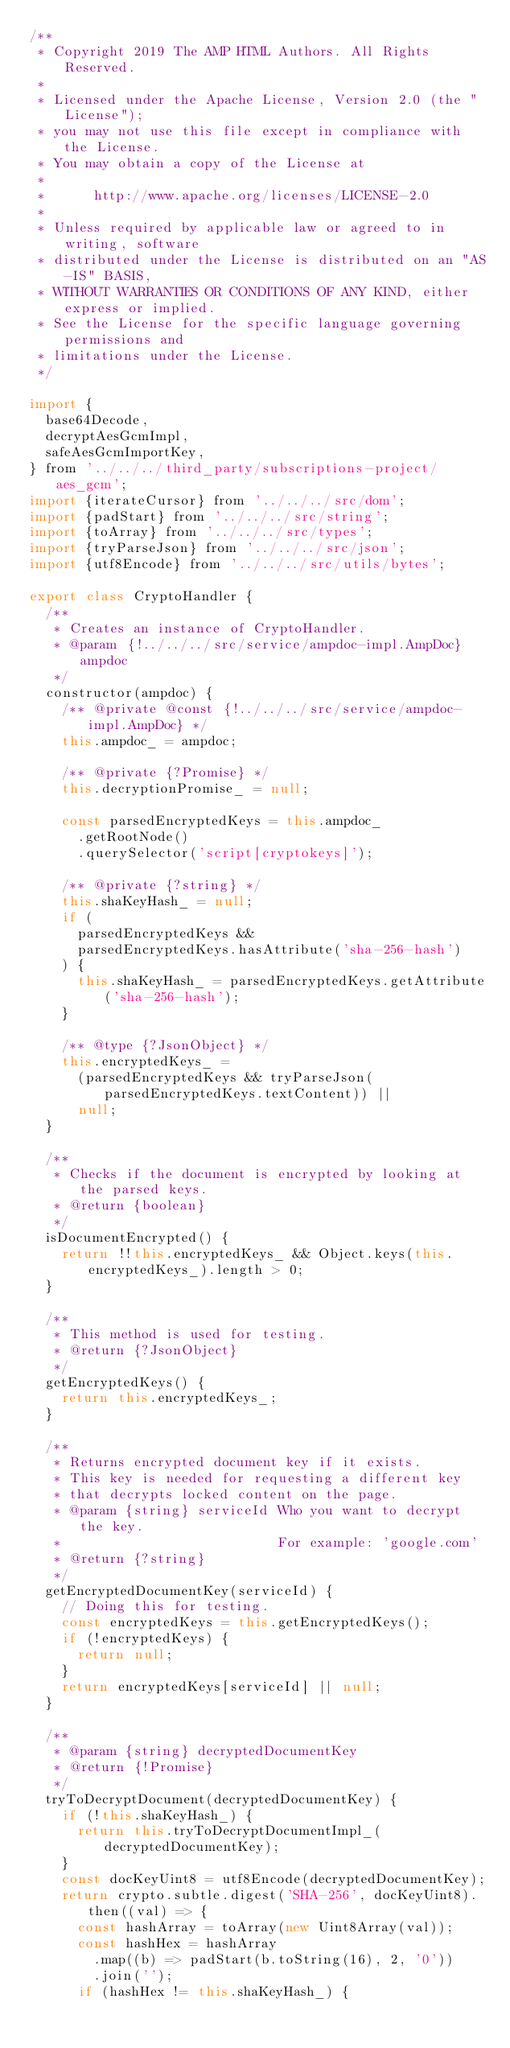Convert code to text. <code><loc_0><loc_0><loc_500><loc_500><_JavaScript_>/**
 * Copyright 2019 The AMP HTML Authors. All Rights Reserved.
 *
 * Licensed under the Apache License, Version 2.0 (the "License");
 * you may not use this file except in compliance with the License.
 * You may obtain a copy of the License at
 *
 *      http://www.apache.org/licenses/LICENSE-2.0
 *
 * Unless required by applicable law or agreed to in writing, software
 * distributed under the License is distributed on an "AS-IS" BASIS,
 * WITHOUT WARRANTIES OR CONDITIONS OF ANY KIND, either express or implied.
 * See the License for the specific language governing permissions and
 * limitations under the License.
 */

import {
  base64Decode,
  decryptAesGcmImpl,
  safeAesGcmImportKey,
} from '../../../third_party/subscriptions-project/aes_gcm';
import {iterateCursor} from '../../../src/dom';
import {padStart} from '../../../src/string';
import {toArray} from '../../../src/types';
import {tryParseJson} from '../../../src/json';
import {utf8Encode} from '../../../src/utils/bytes';

export class CryptoHandler {
  /**
   * Creates an instance of CryptoHandler.
   * @param {!../../../src/service/ampdoc-impl.AmpDoc} ampdoc
   */
  constructor(ampdoc) {
    /** @private @const {!../../../src/service/ampdoc-impl.AmpDoc} */
    this.ampdoc_ = ampdoc;

    /** @private {?Promise} */
    this.decryptionPromise_ = null;

    const parsedEncryptedKeys = this.ampdoc_
      .getRootNode()
      .querySelector('script[cryptokeys]');

    /** @private {?string} */
    this.shaKeyHash_ = null;
    if (
      parsedEncryptedKeys &&
      parsedEncryptedKeys.hasAttribute('sha-256-hash')
    ) {
      this.shaKeyHash_ = parsedEncryptedKeys.getAttribute('sha-256-hash');
    }

    /** @type {?JsonObject} */
    this.encryptedKeys_ =
      (parsedEncryptedKeys && tryParseJson(parsedEncryptedKeys.textContent)) ||
      null;
  }

  /**
   * Checks if the document is encrypted by looking at the parsed keys.
   * @return {boolean}
   */
  isDocumentEncrypted() {
    return !!this.encryptedKeys_ && Object.keys(this.encryptedKeys_).length > 0;
  }

  /**
   * This method is used for testing.
   * @return {?JsonObject}
   */
  getEncryptedKeys() {
    return this.encryptedKeys_;
  }

  /**
   * Returns encrypted document key if it exists.
   * This key is needed for requesting a different key
   * that decrypts locked content on the page.
   * @param {string} serviceId Who you want to decrypt the key.
   *                           For example: 'google.com'
   * @return {?string}
   */
  getEncryptedDocumentKey(serviceId) {
    // Doing this for testing.
    const encryptedKeys = this.getEncryptedKeys();
    if (!encryptedKeys) {
      return null;
    }
    return encryptedKeys[serviceId] || null;
  }

  /**
   * @param {string} decryptedDocumentKey
   * @return {!Promise}
   */
  tryToDecryptDocument(decryptedDocumentKey) {
    if (!this.shaKeyHash_) {
      return this.tryToDecryptDocumentImpl_(decryptedDocumentKey);
    }
    const docKeyUint8 = utf8Encode(decryptedDocumentKey);
    return crypto.subtle.digest('SHA-256', docKeyUint8).then((val) => {
      const hashArray = toArray(new Uint8Array(val));
      const hashHex = hashArray
        .map((b) => padStart(b.toString(16), 2, '0'))
        .join('');
      if (hashHex != this.shaKeyHash_) {</code> 